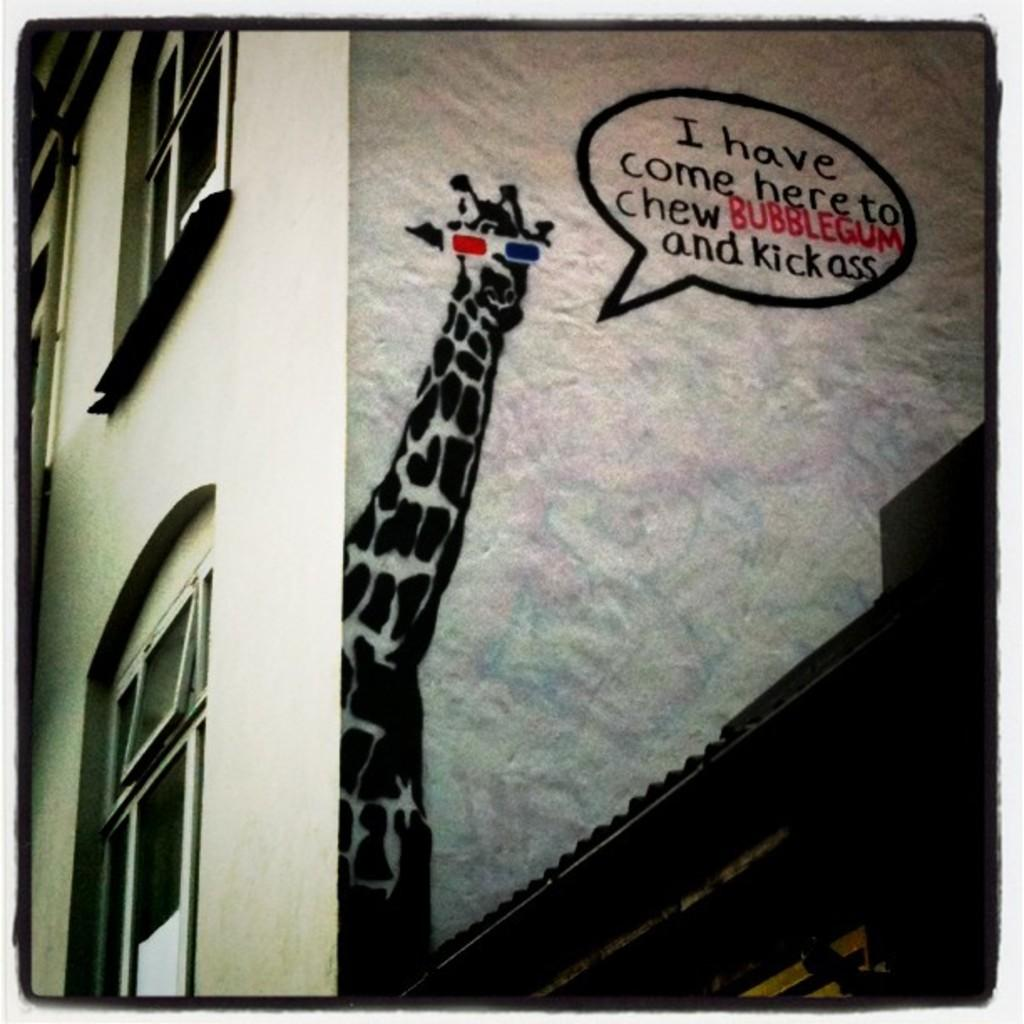What type of structure is present in the image? There is a building in the image. What feature can be observed on the building? The building has windows. Is there any artwork visible on the building? Yes, there is a drawing of a giraffe on the wall of the building. Are there any words or letters present in the image? Yes, there is text written on the wall or somewhere in the image. What type of toothbrush is hanging from the giraffe's mouth in the image? There is no toothbrush present in the image, nor is there a toothbrush hanging from the giraffe's mouth. 